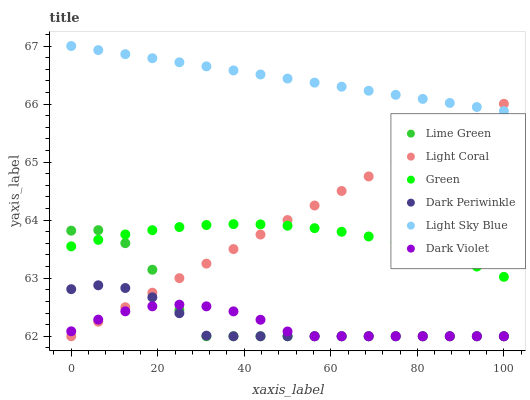Does Dark Violet have the minimum area under the curve?
Answer yes or no. Yes. Does Light Sky Blue have the maximum area under the curve?
Answer yes or no. Yes. Does Light Coral have the minimum area under the curve?
Answer yes or no. No. Does Light Coral have the maximum area under the curve?
Answer yes or no. No. Is Light Coral the smoothest?
Answer yes or no. Yes. Is Lime Green the roughest?
Answer yes or no. Yes. Is Light Sky Blue the smoothest?
Answer yes or no. No. Is Light Sky Blue the roughest?
Answer yes or no. No. Does Dark Violet have the lowest value?
Answer yes or no. Yes. Does Light Sky Blue have the lowest value?
Answer yes or no. No. Does Light Sky Blue have the highest value?
Answer yes or no. Yes. Does Light Coral have the highest value?
Answer yes or no. No. Is Green less than Light Sky Blue?
Answer yes or no. Yes. Is Light Sky Blue greater than Lime Green?
Answer yes or no. Yes. Does Dark Periwinkle intersect Dark Violet?
Answer yes or no. Yes. Is Dark Periwinkle less than Dark Violet?
Answer yes or no. No. Is Dark Periwinkle greater than Dark Violet?
Answer yes or no. No. Does Green intersect Light Sky Blue?
Answer yes or no. No. 